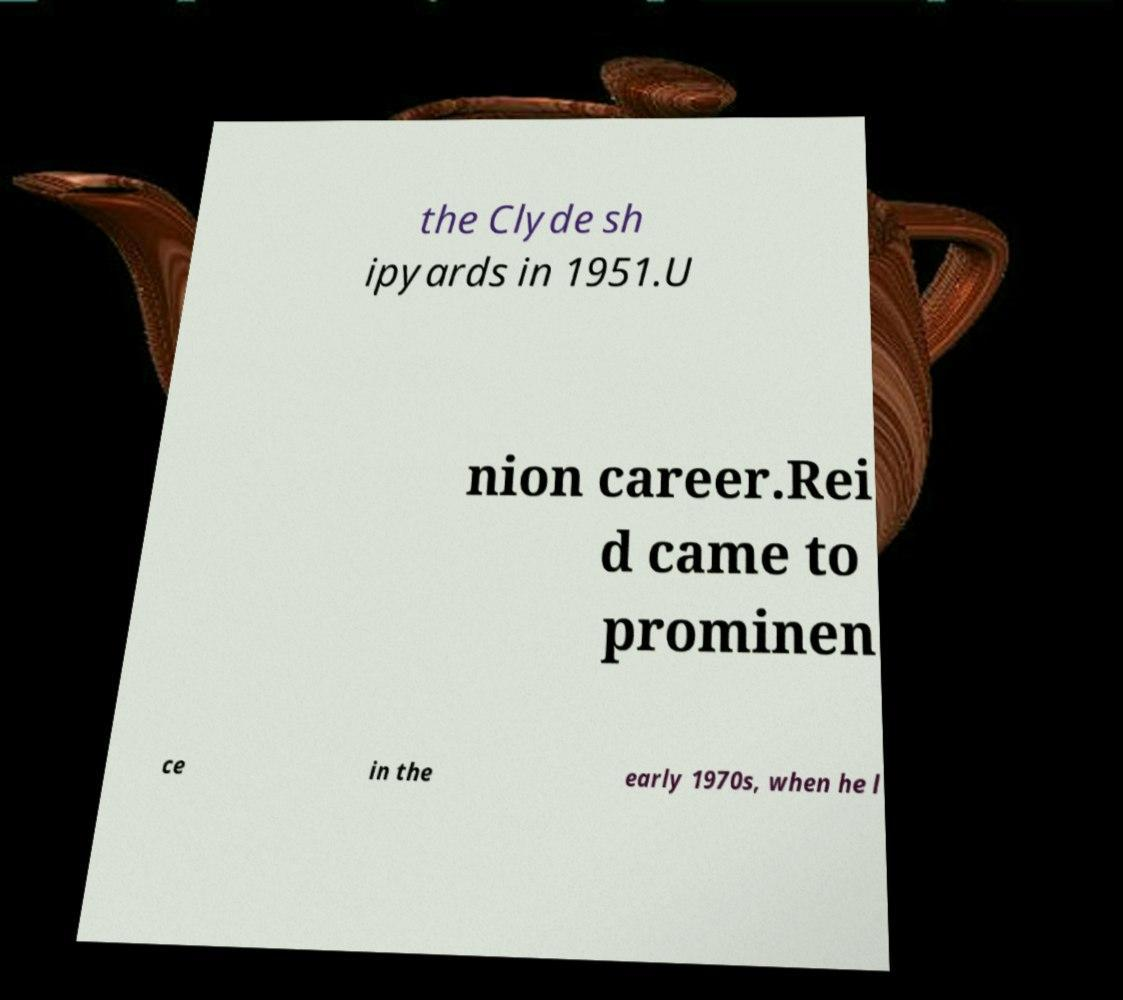There's text embedded in this image that I need extracted. Can you transcribe it verbatim? the Clyde sh ipyards in 1951.U nion career.Rei d came to prominen ce in the early 1970s, when he l 